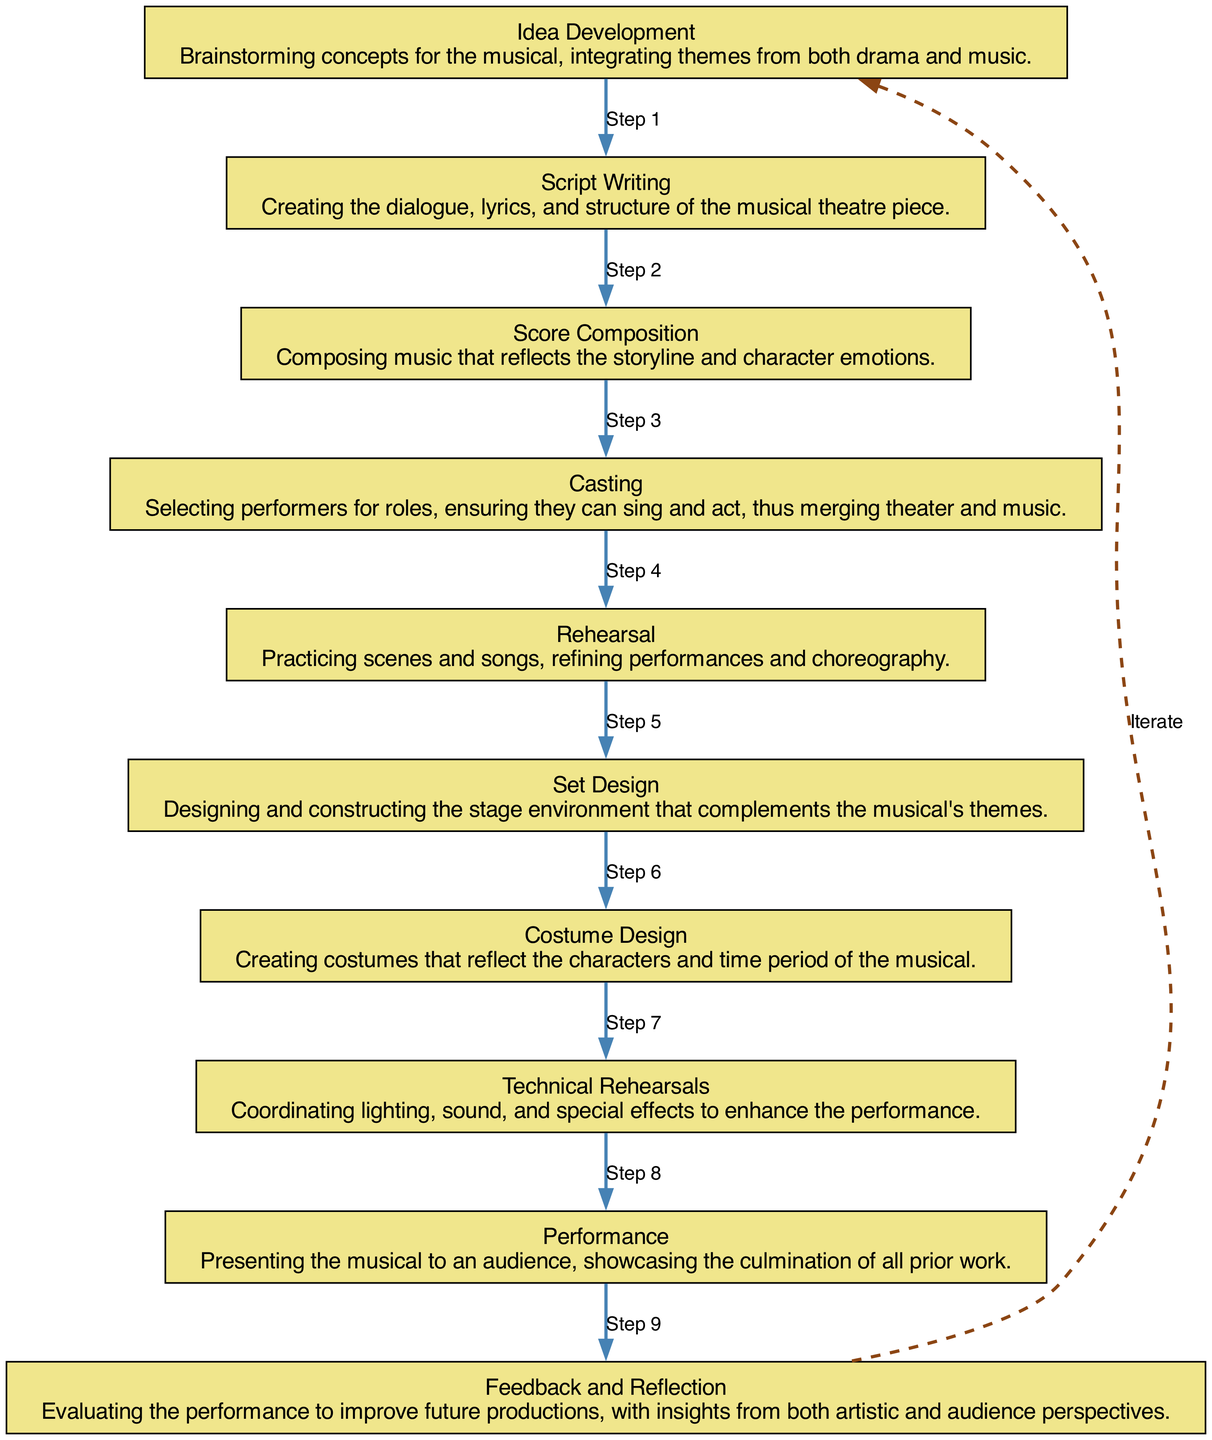What is the first step in the musical theater production process? The first step in the process is "Idea Development," which is where brainstorming concepts occurs.
Answer: Idea Development How many nodes are present in the diagram? The diagram includes ten nodes, each representing a step in the production process.
Answer: 10 What is the last step before the performance? The last step before the performance is "Technical Rehearsals," where all technical elements are coordinated.
Answer: Technical Rehearsals Which two steps are directly connected to "Rehearsal"? "Casting" precedes "Rehearsal," while "Technical Rehearsals" follows it in the sequence of the production process.
Answer: Casting and Technical Rehearsals What activity involves creating the dialogue and lyrics? The activity that involves creating the dialogue and lyrics is "Script Writing."
Answer: Script Writing How does the cycle in the diagram function? The cycle allows for feedback and reflection on the performance, feeding back into the initial stage of "Idea Development."
Answer: Iteration What connects "Score Composition" and "Rehearsal"? "Score Composition" and "Rehearsal" are connected as part of the sequence of events that lead to the performance, with Rehearsal following Composition.
Answer: Edges/Flow What is the focus of the "Set Design" step? The focus of the "Set Design" step is designing and constructing the stage environment that complements the musical's themes.
Answer: Stage environment design What is the purpose of the "Feedback and Reflection" step? The purpose of the "Feedback and Reflection" step is to evaluate the performance to improve future productions.
Answer: Evaluation for improvement 